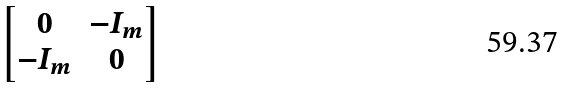<formula> <loc_0><loc_0><loc_500><loc_500>\begin{bmatrix} 0 & - I _ { m } \\ - I _ { m } & 0 \\ \end{bmatrix}</formula> 